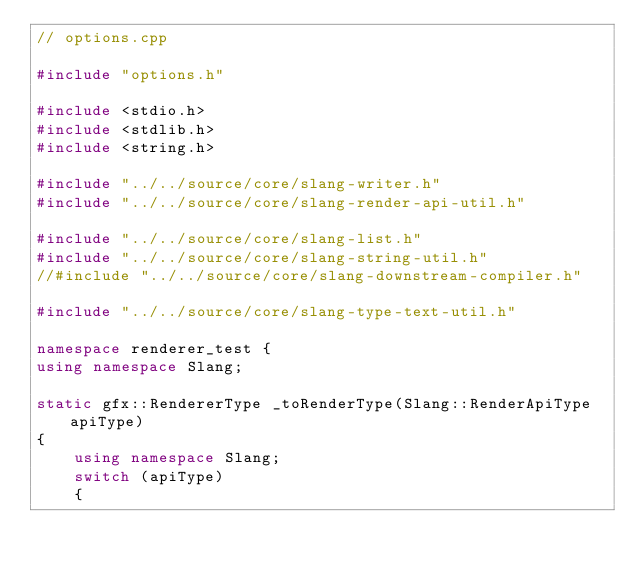Convert code to text. <code><loc_0><loc_0><loc_500><loc_500><_C++_>// options.cpp

#include "options.h"

#include <stdio.h>
#include <stdlib.h>
#include <string.h>

#include "../../source/core/slang-writer.h"
#include "../../source/core/slang-render-api-util.h"

#include "../../source/core/slang-list.h"
#include "../../source/core/slang-string-util.h"
//#include "../../source/core/slang-downstream-compiler.h"

#include "../../source/core/slang-type-text-util.h"

namespace renderer_test {
using namespace Slang;

static gfx::RendererType _toRenderType(Slang::RenderApiType apiType)
{
    using namespace Slang;
    switch (apiType)
    {</code> 